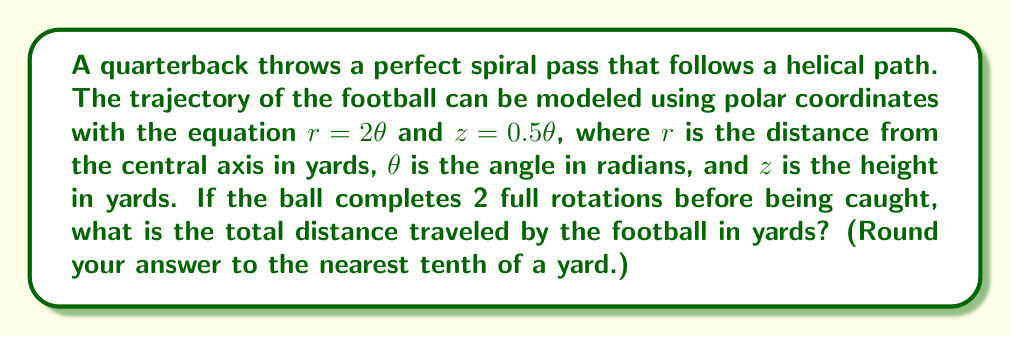Can you answer this question? Let's approach this step-by-step:

1) First, we need to determine the range of $\theta$. Since the ball completes 2 full rotations, $\theta$ goes from 0 to $4\pi$ radians.

2) The path of the football forms a helix. To find the total distance traveled, we need to calculate the arc length of this helix.

3) The arc length of a curve in 3D space is given by the formula:

   $$s = \int_a^b \sqrt{(\frac{dx}{d\theta})^2 + (\frac{dy}{d\theta})^2 + (\frac{dz}{d\theta})^2} d\theta$$

4) In polar coordinates, $x = r\cos\theta$ and $y = r\sin\theta$. We're given $r = 2\theta$ and $z = 0.5\theta$.

5) Let's calculate the derivatives:
   
   $\frac{dx}{d\theta} = \frac{d}{d\theta}(2\theta\cos\theta) = 2\cos\theta - 2\theta\sin\theta$
   
   $\frac{dy}{d\theta} = \frac{d}{d\theta}(2\theta\sin\theta) = 2\sin\theta + 2\theta\cos\theta$
   
   $\frac{dz}{d\theta} = 0.5$

6) Substituting these into our arc length formula:

   $$s = \int_0^{4\pi} \sqrt{(2\cos\theta - 2\theta\sin\theta)^2 + (2\sin\theta + 2\theta\cos\theta)^2 + (0.5)^2} d\theta$$

7) Simplifying the expression under the square root:

   $$s = \int_0^{4\pi} \sqrt{4\cos^2\theta + 4\theta^2\sin^2\theta - 8\theta\sin\theta\cos\theta + 4\sin^2\theta + 4\theta^2\cos^2\theta + 8\theta\sin\theta\cos\theta + 0.25} d\theta$$

   $$s = \int_0^{4\pi} \sqrt{4(\cos^2\theta + \sin^2\theta) + 4\theta^2(\sin^2\theta + \cos^2\theta) + 0.25} d\theta$$

   $$s = \int_0^{4\pi} \sqrt{4 + 4\theta^2 + 0.25} d\theta = \int_0^{4\pi} \sqrt{4\theta^2 + 4.25} d\theta$$

8) This integral doesn't have an elementary antiderivative, so we need to use numerical integration methods to evaluate it.

9) Using a numerical integration tool, we find that the value of this integral is approximately 50.3 yards.
Answer: 50.3 yards 